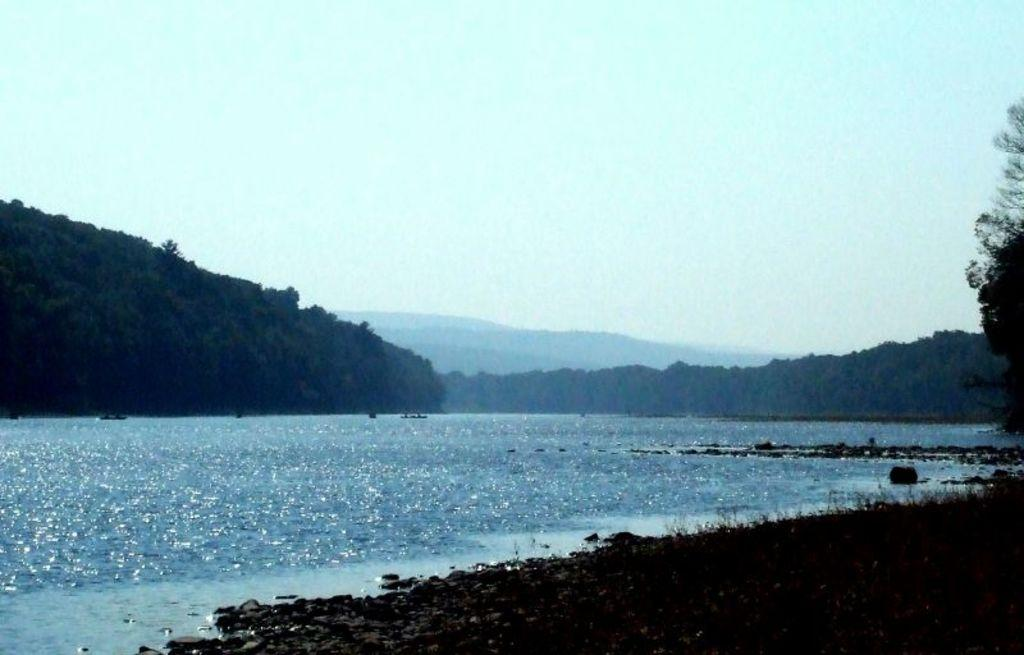What is one of the natural elements visible in the image? Water is visible in the image. What type of vegetation can be seen in the image? There are trees in the image. What geographical features are present in the image? There are hills in the image. What is visible above the landscape in the image? The sky is visible in the image. What type of body of water is present in the image? There is no specific body of water mentioned in the facts provided, only that water is visible in the image. Can you see any bananas growing on the trees in the image? There are no bananas or any indication of fruit-bearing trees in the image; only trees are mentioned. 